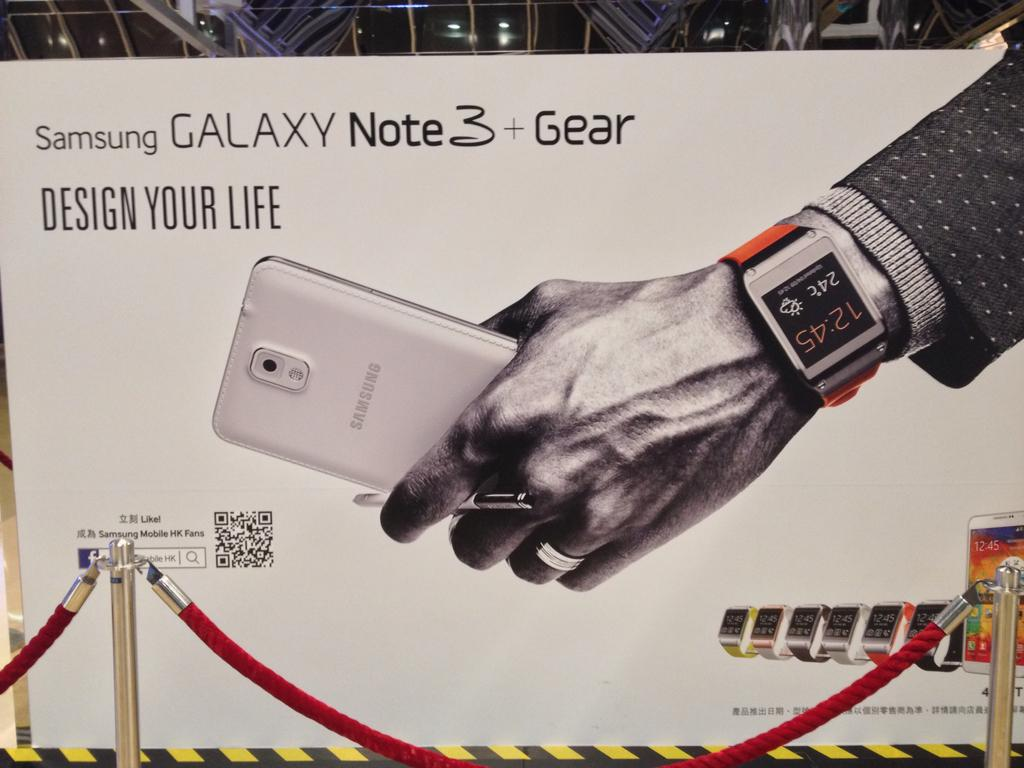<image>
Present a compact description of the photo's key features. Board showing a man holding a Samsung phone and the phrase Design Your Life. 